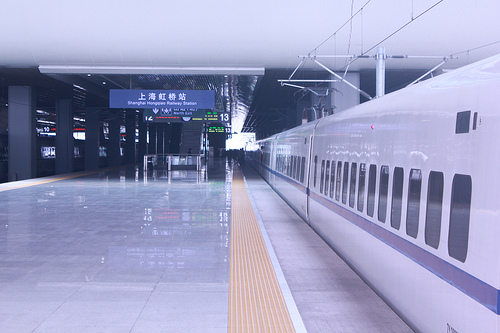<image>
Is the train to the left of the floor? No. The train is not to the left of the floor. From this viewpoint, they have a different horizontal relationship. 